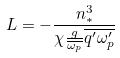Convert formula to latex. <formula><loc_0><loc_0><loc_500><loc_500>L = - \frac { n _ { * } ^ { 3 } } { \chi \frac { g } { \overline { \omega _ { p } } } \overline { q ^ { \prime } \omega _ { p } ^ { \prime } } }</formula> 